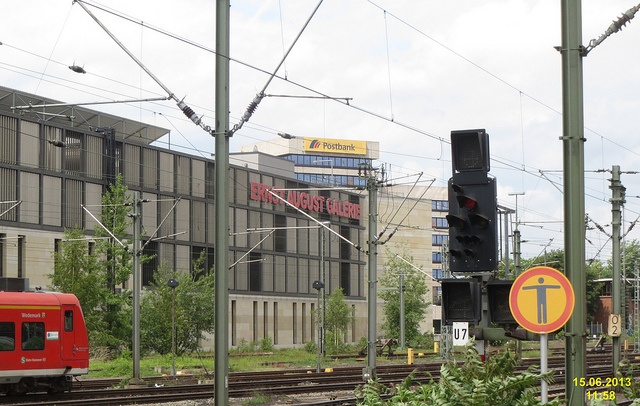Describe the objects in this image and their specific colors. I can see train in white, brown, black, salmon, and maroon tones, traffic light in white, black, gray, and darkgray tones, traffic light in white, black, gray, and darkgray tones, and traffic light in white, black, gray, and darkgray tones in this image. 